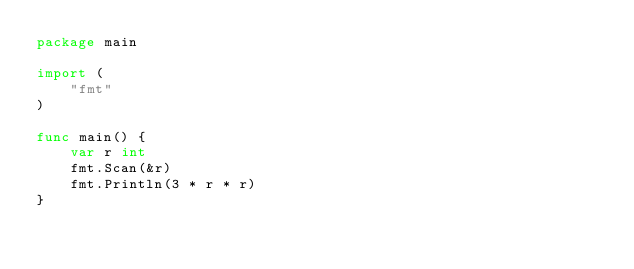Convert code to text. <code><loc_0><loc_0><loc_500><loc_500><_Go_>package main

import (
	"fmt"
)

func main() {
	var r int
	fmt.Scan(&r)
	fmt.Println(3 * r * r)
}
</code> 